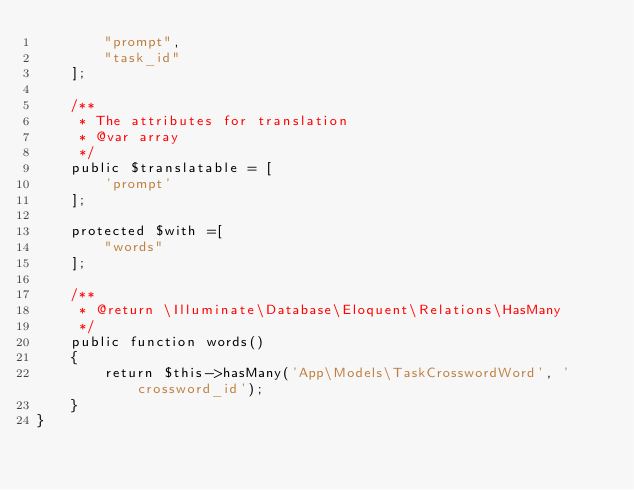Convert code to text. <code><loc_0><loc_0><loc_500><loc_500><_PHP_>        "prompt",
        "task_id"
    ];

    /**
     * The attributes for translation
     * @var array
     */
    public $translatable = [
        'prompt'
    ];

    protected $with =[
        "words"
    ];

    /**
     * @return \Illuminate\Database\Eloquent\Relations\HasMany
     */
    public function words()
    {
        return $this->hasMany('App\Models\TaskCrosswordWord', 'crossword_id');
    }
}
</code> 